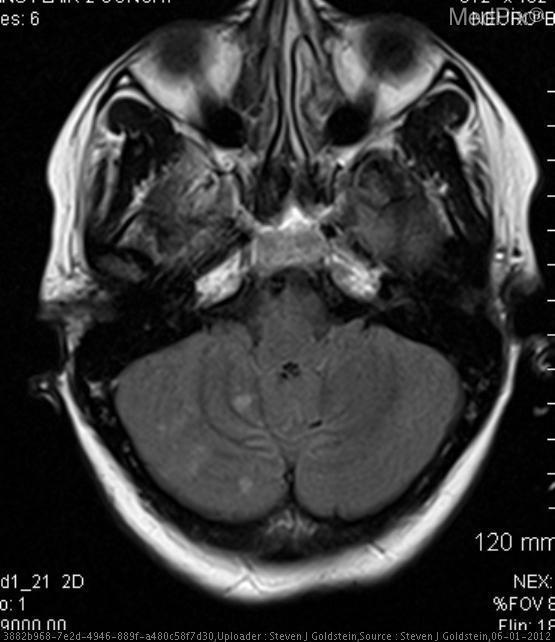How would you describe the r vertebral artery shape?
Quick response, please. Short section irregular contour. What type of image modality is this?
Short answer required. Mr flair. Which image modality is this?
Answer briefly. Mr flair. In which area of the brain are the infarcts found?
Be succinct. Right cerebellum. Where are the infarcts located?
Short answer required. Right cerebellum. Does the r vertebral artery appear normal?
Give a very brief answer. No. Is the right vertebral artery normal?
Answer briefly. No. 